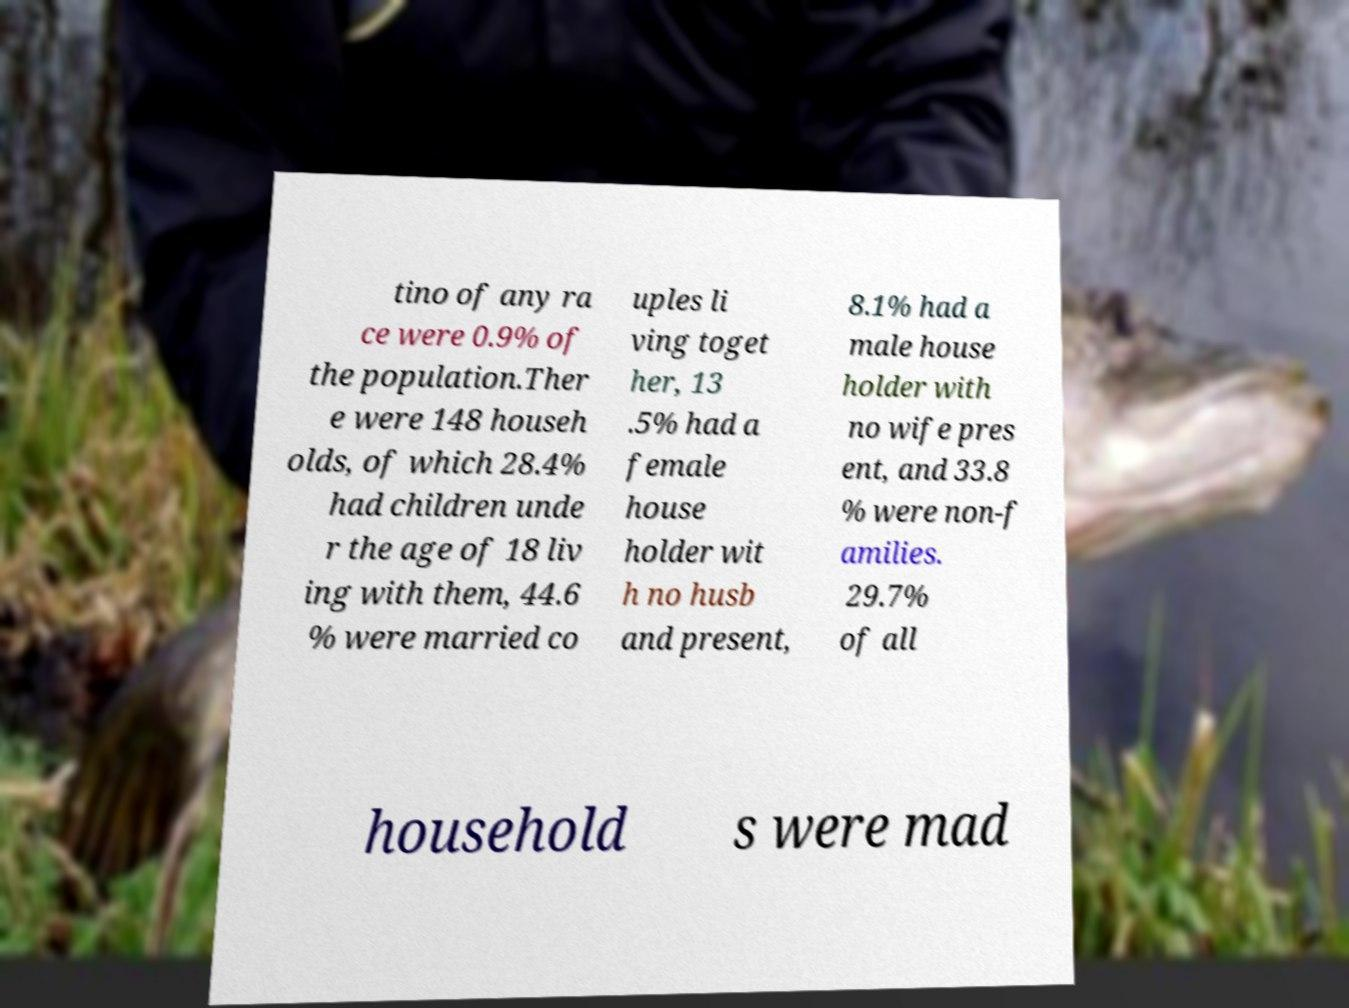Could you assist in decoding the text presented in this image and type it out clearly? tino of any ra ce were 0.9% of the population.Ther e were 148 househ olds, of which 28.4% had children unde r the age of 18 liv ing with them, 44.6 % were married co uples li ving toget her, 13 .5% had a female house holder wit h no husb and present, 8.1% had a male house holder with no wife pres ent, and 33.8 % were non-f amilies. 29.7% of all household s were mad 